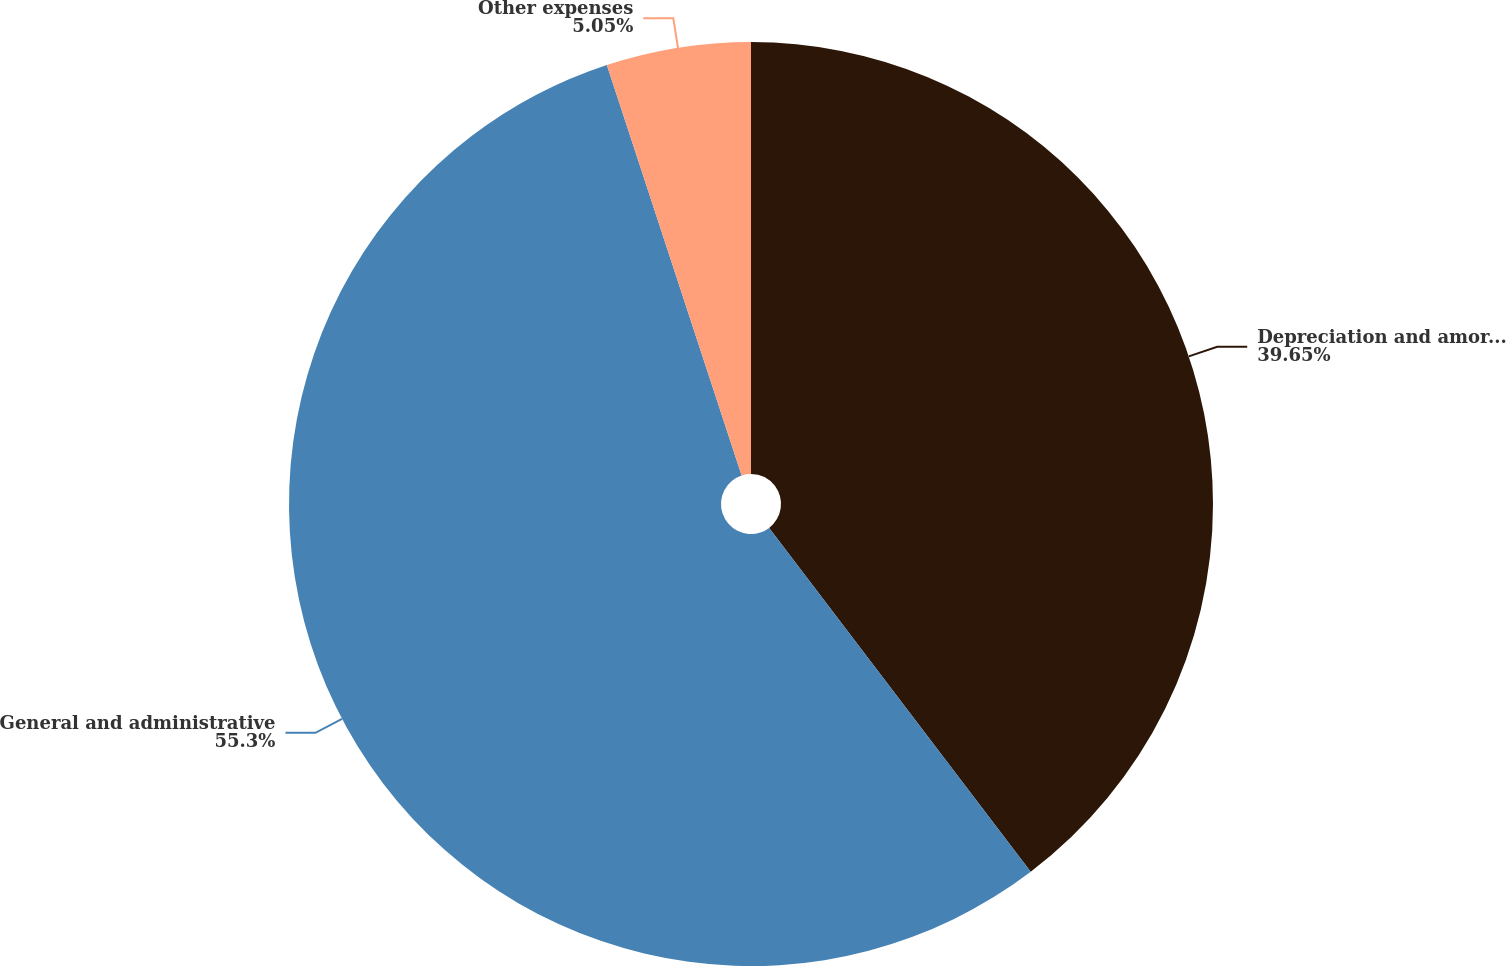Convert chart. <chart><loc_0><loc_0><loc_500><loc_500><pie_chart><fcel>Depreciation and amortization<fcel>General and administrative<fcel>Other expenses<nl><fcel>39.65%<fcel>55.3%<fcel>5.05%<nl></chart> 